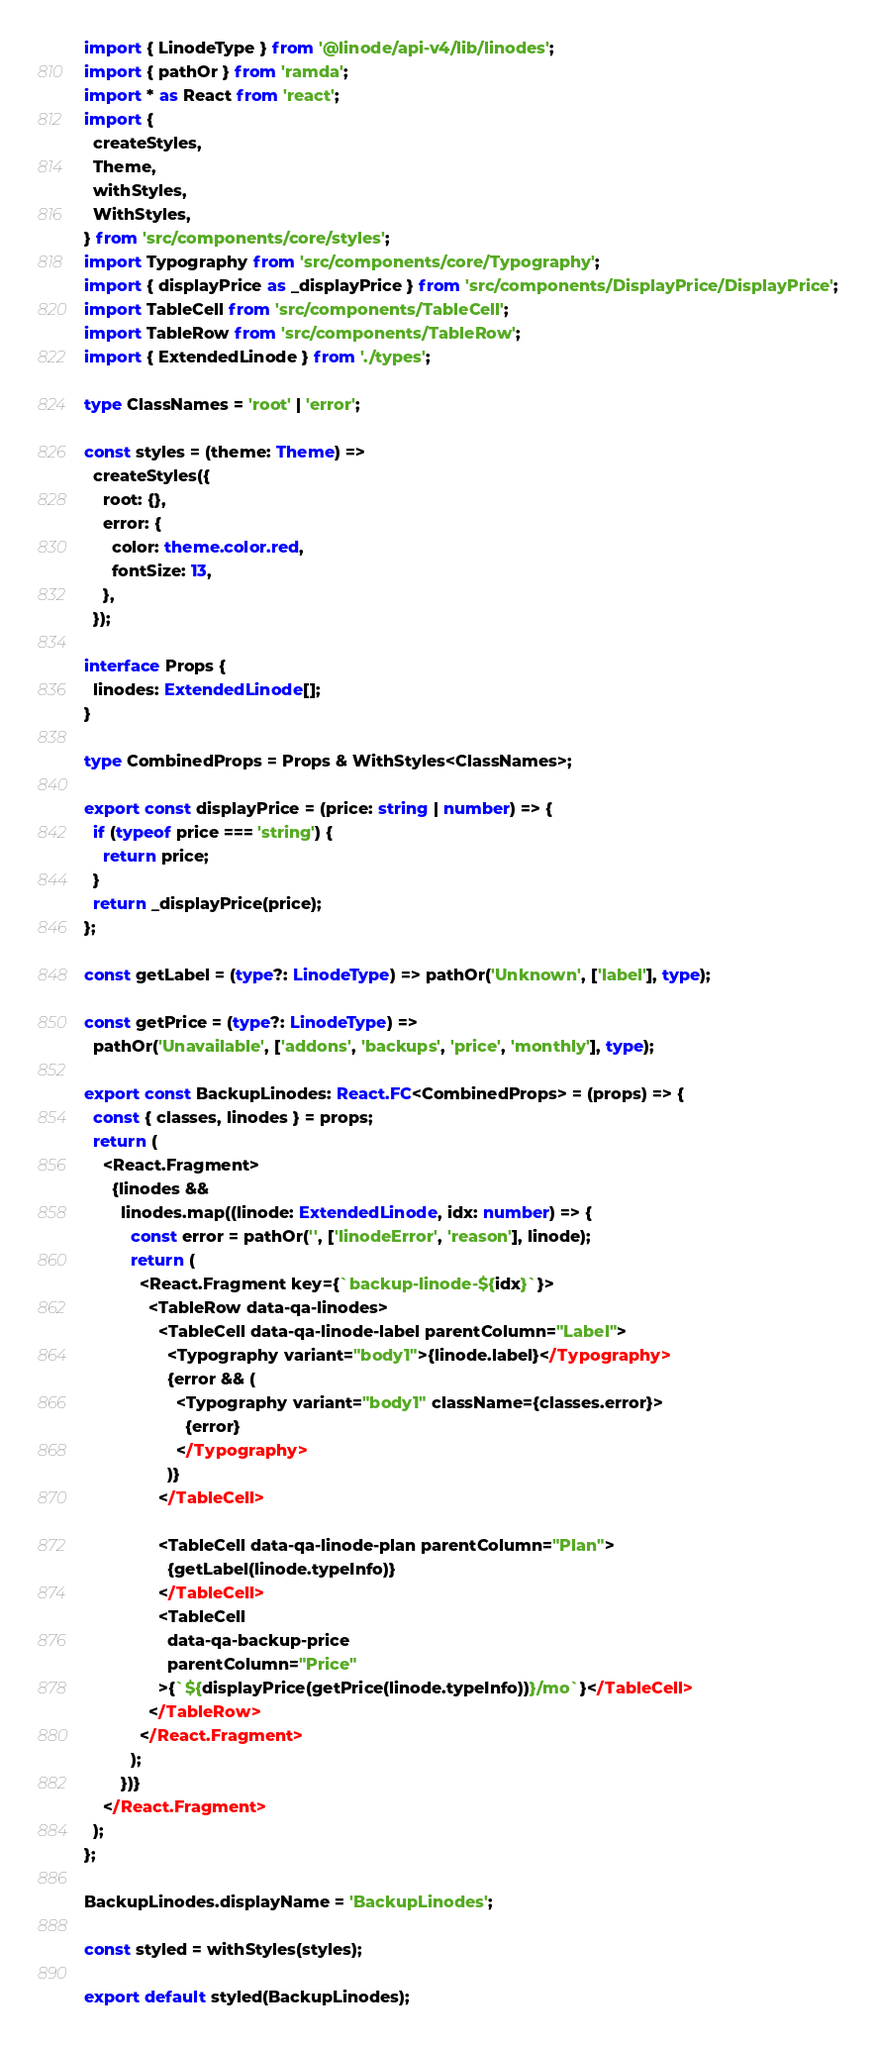Convert code to text. <code><loc_0><loc_0><loc_500><loc_500><_TypeScript_>import { LinodeType } from '@linode/api-v4/lib/linodes';
import { pathOr } from 'ramda';
import * as React from 'react';
import {
  createStyles,
  Theme,
  withStyles,
  WithStyles,
} from 'src/components/core/styles';
import Typography from 'src/components/core/Typography';
import { displayPrice as _displayPrice } from 'src/components/DisplayPrice/DisplayPrice';
import TableCell from 'src/components/TableCell';
import TableRow from 'src/components/TableRow';
import { ExtendedLinode } from './types';

type ClassNames = 'root' | 'error';

const styles = (theme: Theme) =>
  createStyles({
    root: {},
    error: {
      color: theme.color.red,
      fontSize: 13,
    },
  });

interface Props {
  linodes: ExtendedLinode[];
}

type CombinedProps = Props & WithStyles<ClassNames>;

export const displayPrice = (price: string | number) => {
  if (typeof price === 'string') {
    return price;
  }
  return _displayPrice(price);
};

const getLabel = (type?: LinodeType) => pathOr('Unknown', ['label'], type);

const getPrice = (type?: LinodeType) =>
  pathOr('Unavailable', ['addons', 'backups', 'price', 'monthly'], type);

export const BackupLinodes: React.FC<CombinedProps> = (props) => {
  const { classes, linodes } = props;
  return (
    <React.Fragment>
      {linodes &&
        linodes.map((linode: ExtendedLinode, idx: number) => {
          const error = pathOr('', ['linodeError', 'reason'], linode);
          return (
            <React.Fragment key={`backup-linode-${idx}`}>
              <TableRow data-qa-linodes>
                <TableCell data-qa-linode-label parentColumn="Label">
                  <Typography variant="body1">{linode.label}</Typography>
                  {error && (
                    <Typography variant="body1" className={classes.error}>
                      {error}
                    </Typography>
                  )}
                </TableCell>

                <TableCell data-qa-linode-plan parentColumn="Plan">
                  {getLabel(linode.typeInfo)}
                </TableCell>
                <TableCell
                  data-qa-backup-price
                  parentColumn="Price"
                >{`${displayPrice(getPrice(linode.typeInfo))}/mo`}</TableCell>
              </TableRow>
            </React.Fragment>
          );
        })}
    </React.Fragment>
  );
};

BackupLinodes.displayName = 'BackupLinodes';

const styled = withStyles(styles);

export default styled(BackupLinodes);
</code> 